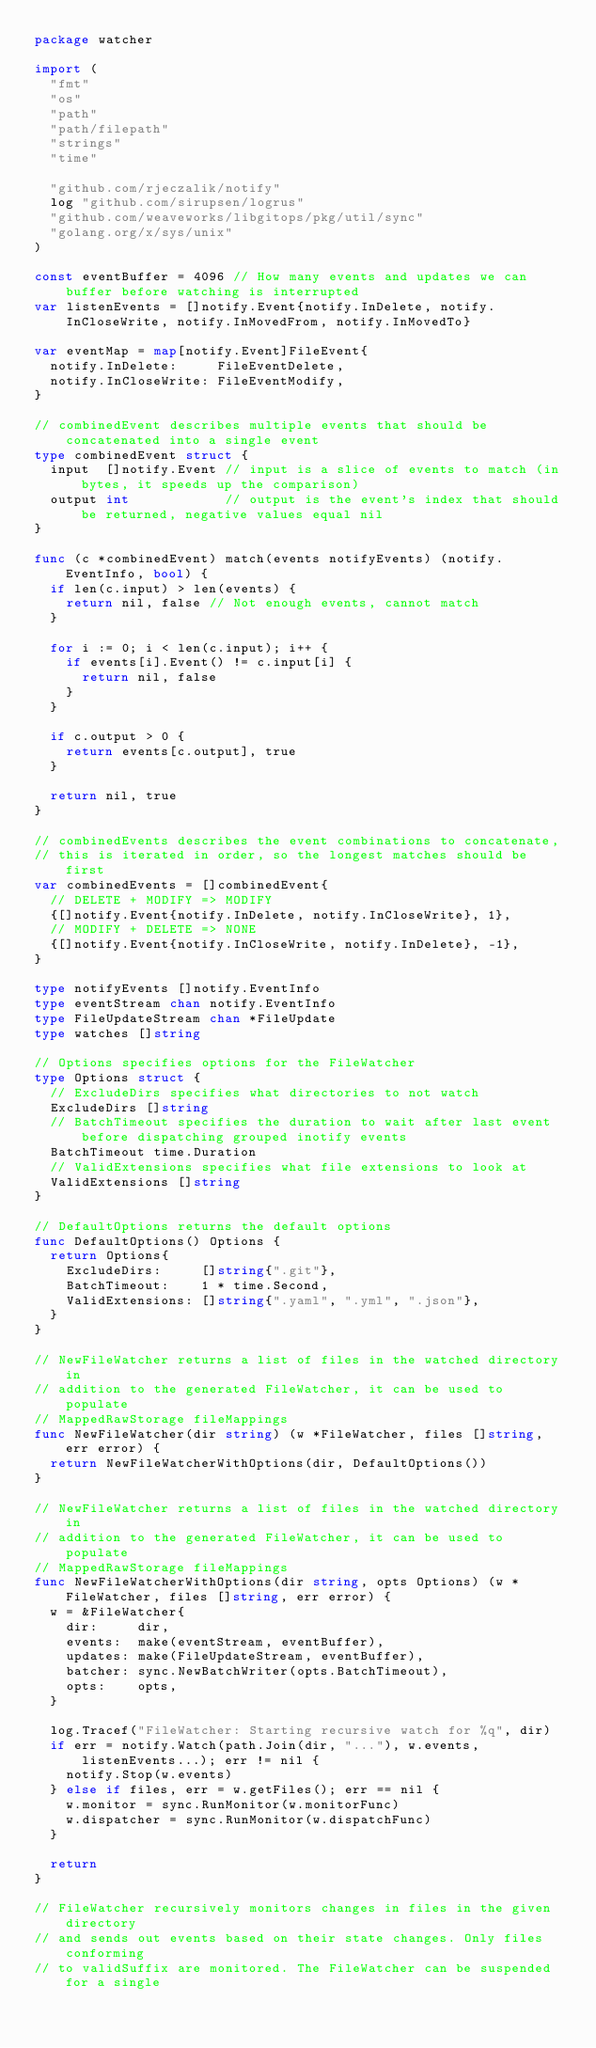<code> <loc_0><loc_0><loc_500><loc_500><_Go_>package watcher

import (
	"fmt"
	"os"
	"path"
	"path/filepath"
	"strings"
	"time"

	"github.com/rjeczalik/notify"
	log "github.com/sirupsen/logrus"
	"github.com/weaveworks/libgitops/pkg/util/sync"
	"golang.org/x/sys/unix"
)

const eventBuffer = 4096 // How many events and updates we can buffer before watching is interrupted
var listenEvents = []notify.Event{notify.InDelete, notify.InCloseWrite, notify.InMovedFrom, notify.InMovedTo}

var eventMap = map[notify.Event]FileEvent{
	notify.InDelete:     FileEventDelete,
	notify.InCloseWrite: FileEventModify,
}

// combinedEvent describes multiple events that should be concatenated into a single event
type combinedEvent struct {
	input  []notify.Event // input is a slice of events to match (in bytes, it speeds up the comparison)
	output int            // output is the event's index that should be returned, negative values equal nil
}

func (c *combinedEvent) match(events notifyEvents) (notify.EventInfo, bool) {
	if len(c.input) > len(events) {
		return nil, false // Not enough events, cannot match
	}

	for i := 0; i < len(c.input); i++ {
		if events[i].Event() != c.input[i] {
			return nil, false
		}
	}

	if c.output > 0 {
		return events[c.output], true
	}

	return nil, true
}

// combinedEvents describes the event combinations to concatenate,
// this is iterated in order, so the longest matches should be first
var combinedEvents = []combinedEvent{
	// DELETE + MODIFY => MODIFY
	{[]notify.Event{notify.InDelete, notify.InCloseWrite}, 1},
	// MODIFY + DELETE => NONE
	{[]notify.Event{notify.InCloseWrite, notify.InDelete}, -1},
}

type notifyEvents []notify.EventInfo
type eventStream chan notify.EventInfo
type FileUpdateStream chan *FileUpdate
type watches []string

// Options specifies options for the FileWatcher
type Options struct {
	// ExcludeDirs specifies what directories to not watch
	ExcludeDirs []string
	// BatchTimeout specifies the duration to wait after last event before dispatching grouped inotify events
	BatchTimeout time.Duration
	// ValidExtensions specifies what file extensions to look at
	ValidExtensions []string
}

// DefaultOptions returns the default options
func DefaultOptions() Options {
	return Options{
		ExcludeDirs:     []string{".git"},
		BatchTimeout:    1 * time.Second,
		ValidExtensions: []string{".yaml", ".yml", ".json"},
	}
}

// NewFileWatcher returns a list of files in the watched directory in
// addition to the generated FileWatcher, it can be used to populate
// MappedRawStorage fileMappings
func NewFileWatcher(dir string) (w *FileWatcher, files []string, err error) {
	return NewFileWatcherWithOptions(dir, DefaultOptions())
}

// NewFileWatcher returns a list of files in the watched directory in
// addition to the generated FileWatcher, it can be used to populate
// MappedRawStorage fileMappings
func NewFileWatcherWithOptions(dir string, opts Options) (w *FileWatcher, files []string, err error) {
	w = &FileWatcher{
		dir:     dir,
		events:  make(eventStream, eventBuffer),
		updates: make(FileUpdateStream, eventBuffer),
		batcher: sync.NewBatchWriter(opts.BatchTimeout),
		opts:    opts,
	}

	log.Tracef("FileWatcher: Starting recursive watch for %q", dir)
	if err = notify.Watch(path.Join(dir, "..."), w.events, listenEvents...); err != nil {
		notify.Stop(w.events)
	} else if files, err = w.getFiles(); err == nil {
		w.monitor = sync.RunMonitor(w.monitorFunc)
		w.dispatcher = sync.RunMonitor(w.dispatchFunc)
	}

	return
}

// FileWatcher recursively monitors changes in files in the given directory
// and sends out events based on their state changes. Only files conforming
// to validSuffix are monitored. The FileWatcher can be suspended for a single</code> 